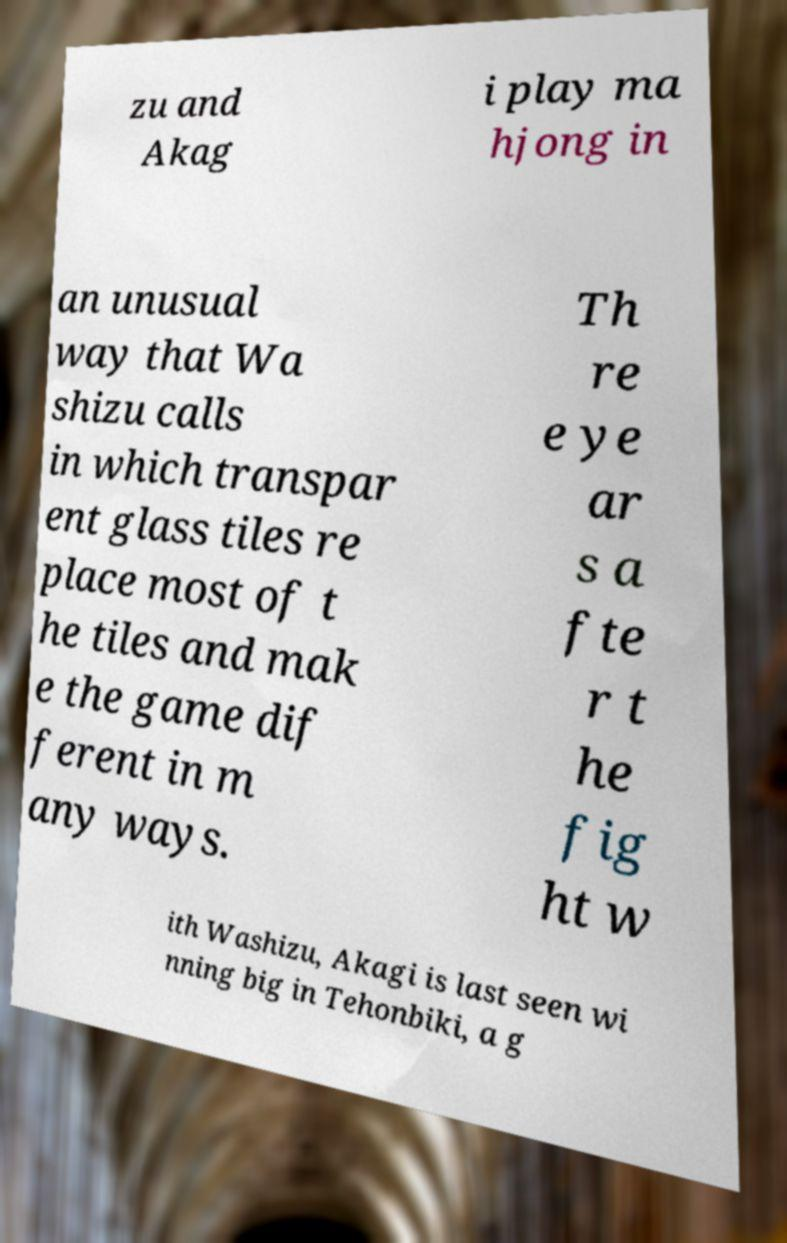Please identify and transcribe the text found in this image. zu and Akag i play ma hjong in an unusual way that Wa shizu calls in which transpar ent glass tiles re place most of t he tiles and mak e the game dif ferent in m any ways. Th re e ye ar s a fte r t he fig ht w ith Washizu, Akagi is last seen wi nning big in Tehonbiki, a g 